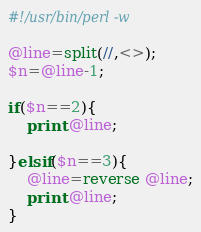Convert code to text. <code><loc_0><loc_0><loc_500><loc_500><_Perl_>#!/usr/bin/perl -w

@line=split(//,<>);
$n=@line-1;

if($n==2){
    print @line;

}elsif($n==3){
    @line=reverse @line;
    print @line;
}
</code> 